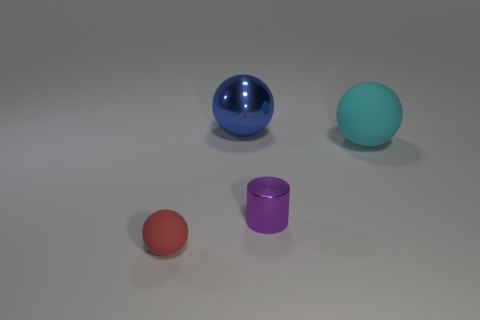Subtract all big balls. How many balls are left? 1 Add 1 green objects. How many objects exist? 5 Subtract all cylinders. How many objects are left? 3 Subtract all purple balls. Subtract all cyan cylinders. How many balls are left? 3 Add 4 big brown metal cylinders. How many big brown metal cylinders exist? 4 Subtract 0 cyan blocks. How many objects are left? 4 Subtract all red spheres. Subtract all small rubber spheres. How many objects are left? 2 Add 3 tiny red balls. How many tiny red balls are left? 4 